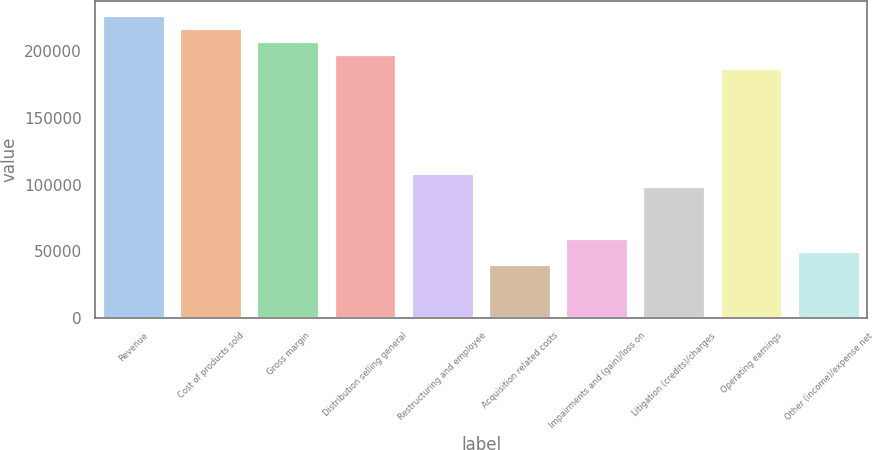Convert chart to OTSL. <chart><loc_0><loc_0><loc_500><loc_500><bar_chart><fcel>Revenue<fcel>Cost of products sold<fcel>Gross margin<fcel>Distribution selling general<fcel>Restructuring and employee<fcel>Acquisition related costs<fcel>Impairments and (gain)/loss on<fcel>Litigation (credits)/charges<fcel>Operating earnings<fcel>Other (income)/expense net<nl><fcel>226556<fcel>216706<fcel>206856<fcel>197005<fcel>108353<fcel>39401.2<fcel>59101.8<fcel>98502.8<fcel>187155<fcel>49251.5<nl></chart> 